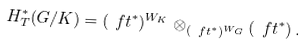<formula> <loc_0><loc_0><loc_500><loc_500>H ^ { * } _ { T } ( G / K ) = ( \ f t ^ { * } ) ^ { W _ { K } } \otimes _ { ( \ f t ^ { * } ) ^ { W _ { G } } } ( \ f t ^ { * } ) \, .</formula> 